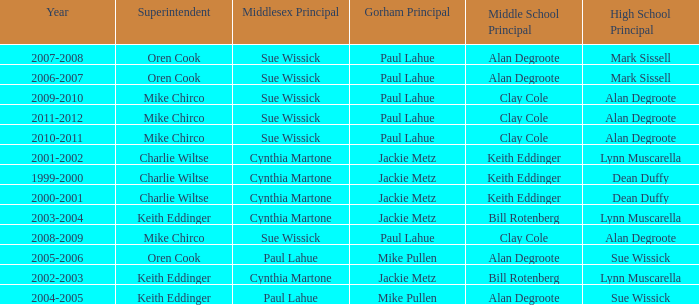How many middlesex principals were there in 2000-2001? 1.0. 